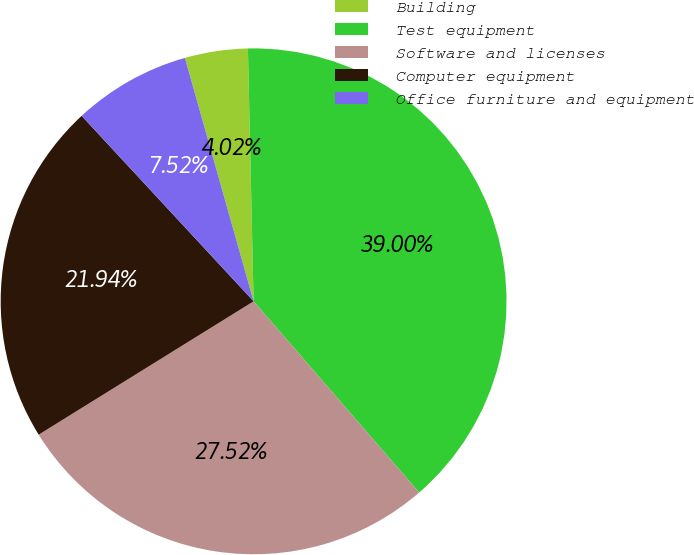<chart> <loc_0><loc_0><loc_500><loc_500><pie_chart><fcel>Building<fcel>Test equipment<fcel>Software and licenses<fcel>Computer equipment<fcel>Office furniture and equipment<nl><fcel>4.02%<fcel>39.0%<fcel>27.52%<fcel>21.94%<fcel>7.52%<nl></chart> 